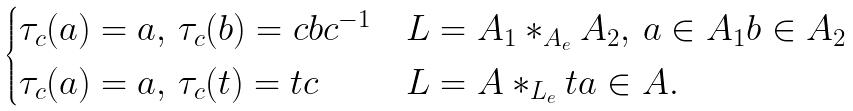<formula> <loc_0><loc_0><loc_500><loc_500>\begin{cases} \tau _ { c } ( a ) = a , \, \tau _ { c } ( b ) = c b c ^ { - 1 } & L = A _ { 1 } \ast _ { A _ { e } } A _ { 2 } , \, a \in A _ { 1 } b \in A _ { 2 } \\ \tau _ { c } ( a ) = a , \, \tau _ { c } ( t ) = t c & L = A \ast _ { L _ { e } } t a \in A . \end{cases}</formula> 